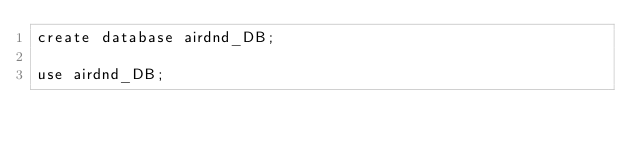<code> <loc_0><loc_0><loc_500><loc_500><_SQL_>create database airdnd_DB;

use airdnd_DB;</code> 